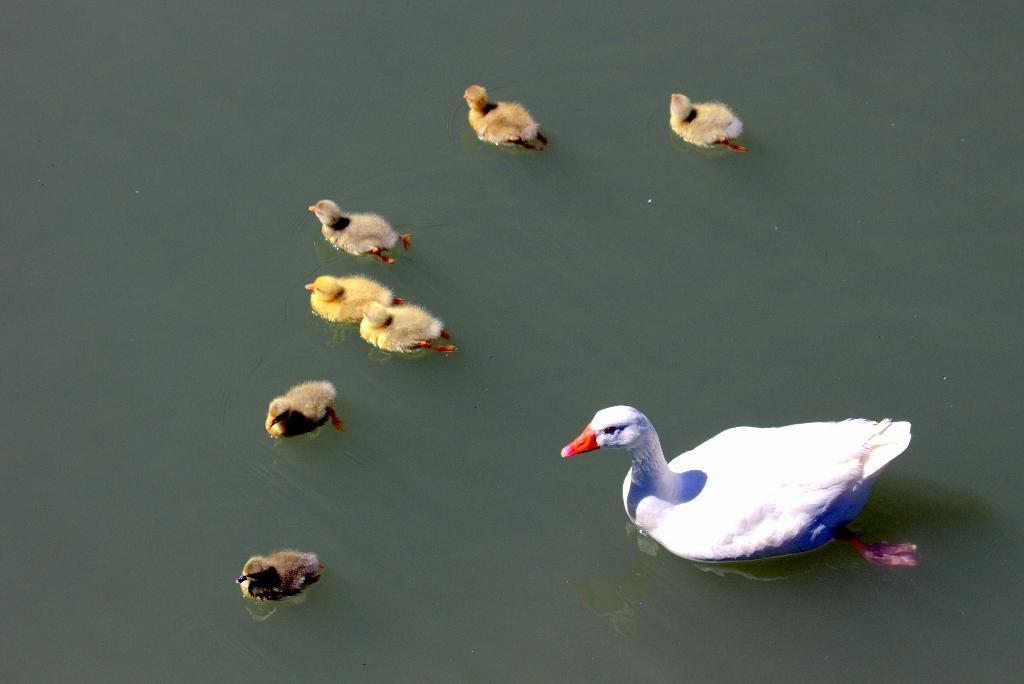What animal is the main subject of the image? There is a duck in the image. Does the duck have any offspring in the image? Yes, the duck has ducklings in the image. Where are the duck and ducklings located in the image? The duck and ducklings are on the surface of the water in the image. What type of maid can be seen cleaning the afterthought in the image? There is no maid or afterthought present in the image; it features a duck with ducklings on the surface of the water. 